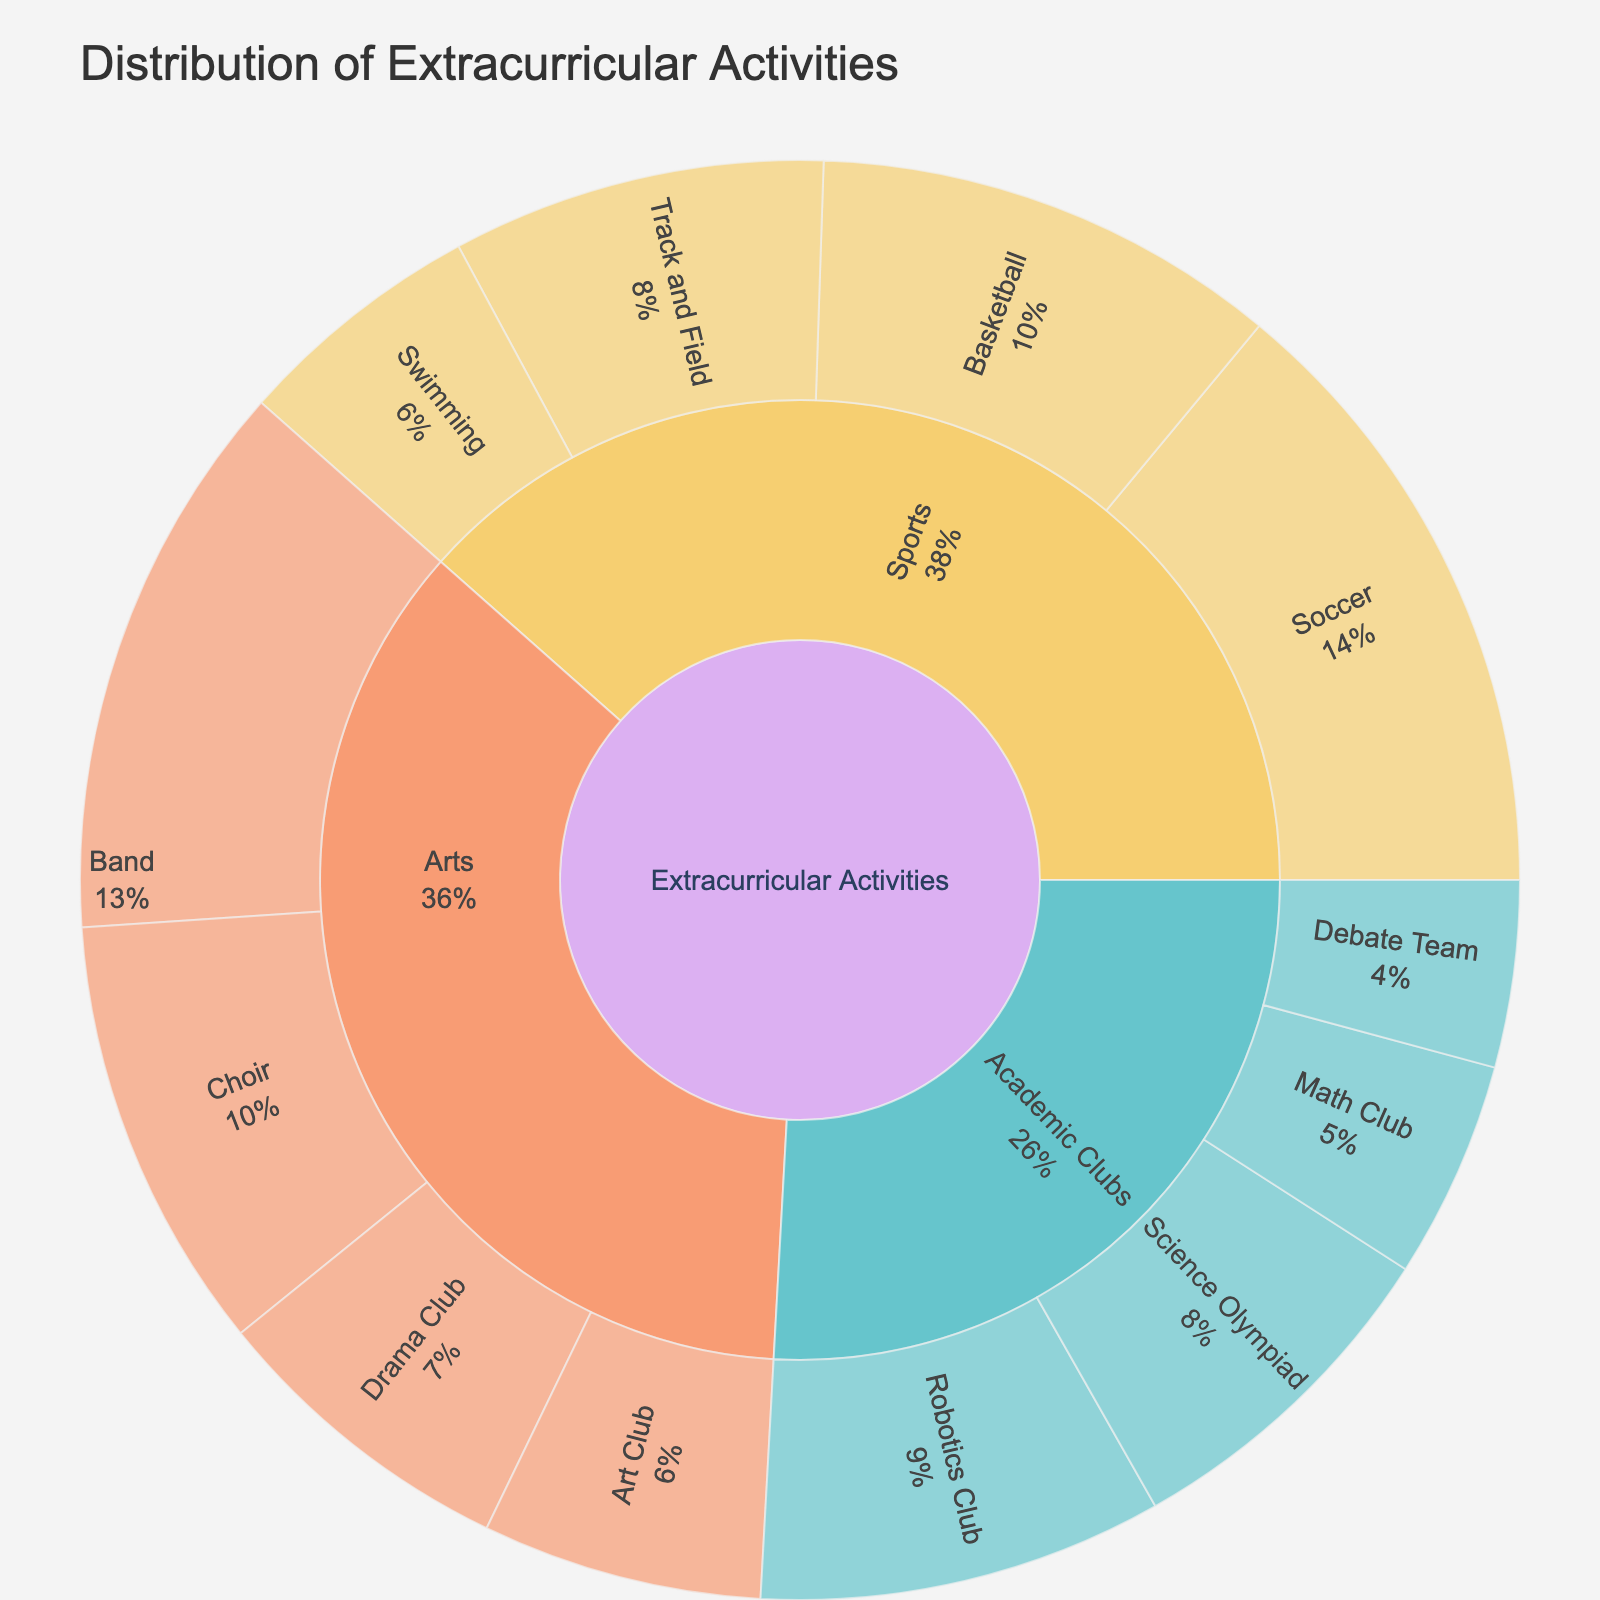what's the title of the figure? Look at the top of the figure where the title is usually placed.
Answer: Distribution of Extracurricular Activities Which activity in the Sports subcategory has the highest participation? Identify the segments under Sports and compare the participation numbers shown.
Answer: Soccer How many more students participate in Basketball compared to Track and Field? Find the participation numbers for Basketball and Track and Field, and subtract the latter from the former. 15 - 12 = 3
Answer: 3 What percentage of students are in the Band compared to the total Extracurricular Activities? The Band participation is 18. Sum all participation numbers: 15 + 20 + 12 + 8 + 10 + 18 + 14 + 9 + 7 + 11 + 6 + 13 = 143. Percentage: (18/143) * 100 ≈ 12.6%
Answer: 12.6% Which subcategory has the least overall participation among students? Sum the participation numbers for each subcategory: 
Sports: (15 + 20 + 12 + 8 = 55), 
Arts: (10 + 18 + 14 + 9 = 51), 
Academic Clubs: (7 + 11 + 6 + 13 = 37). The least is Academic Clubs with 37.
Answer: Academic Clubs Which activity has more participation: Choir or Science Olympiad? Compare the participation numbers of Choir and Science Olympiad. Choir is 14, Science Olympiad is 11.
Answer: Choir What's the total number of students participating in Sports activities? Sum the participation numbers for all activities in the Sports subcategory: 15 + 20 + 12 + 8 = 55
Answer: 55 What is the most popular activity in the figure? Identify the activity with the highest participation number from the plot.
Answer: Soccer Compare the participation in Robotics Club and Drama Club Look at the participation numbers for Robotics Club (13) and Drama Club (10) and state which one is higher.
Answer: Robotics Club How many students are involved in Arts activities? Sum the participation numbers for all activities in the Arts subcategory: 10 + 18 + 14 + 9 = 51.
Answer: 51 